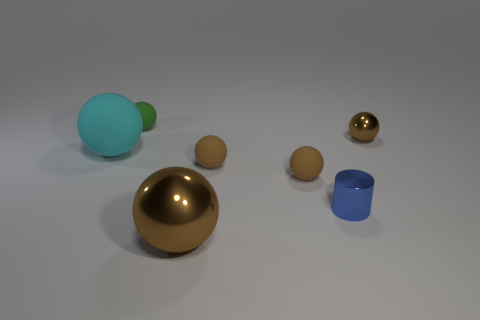Add 3 big purple shiny cubes. How many objects exist? 10 Subtract all small brown rubber balls. How many balls are left? 4 Subtract all cyan balls. How many balls are left? 5 Subtract all cylinders. How many objects are left? 6 Subtract 1 cylinders. How many cylinders are left? 0 Subtract all red cylinders. Subtract all gray blocks. How many cylinders are left? 1 Subtract all brown cylinders. How many brown spheres are left? 4 Subtract all green objects. Subtract all big matte things. How many objects are left? 5 Add 7 large metal objects. How many large metal objects are left? 8 Add 4 matte objects. How many matte objects exist? 8 